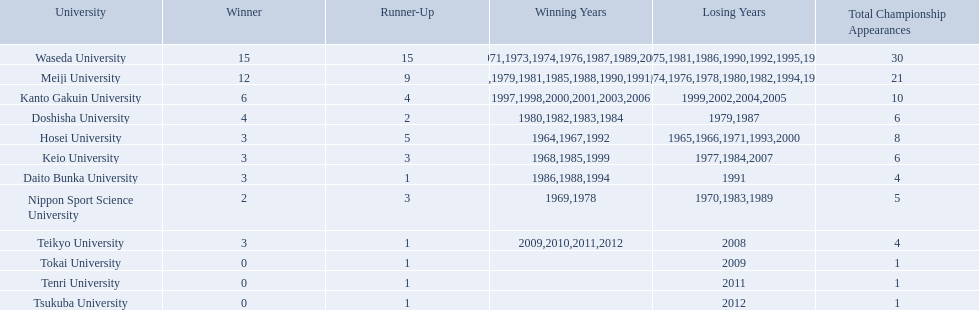Which university had 6 wins? Kanto Gakuin University. Which university had 12 wins? Meiji University. Which university had more than 12 wins? Waseda University. 